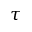Convert formula to latex. <formula><loc_0><loc_0><loc_500><loc_500>\tau</formula> 